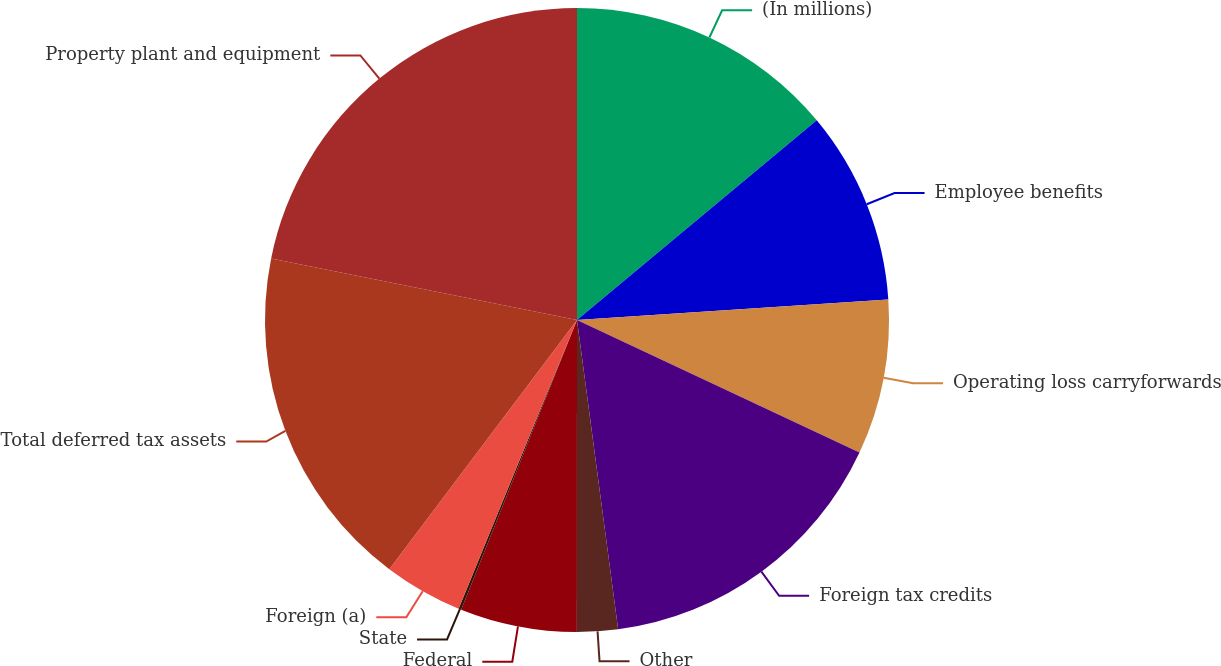Convert chart. <chart><loc_0><loc_0><loc_500><loc_500><pie_chart><fcel>(In millions)<fcel>Employee benefits<fcel>Operating loss carryforwards<fcel>Foreign tax credits<fcel>Other<fcel>Federal<fcel>State<fcel>Foreign (a)<fcel>Total deferred tax assets<fcel>Property plant and equipment<nl><fcel>13.95%<fcel>10.0%<fcel>8.03%<fcel>15.92%<fcel>2.11%<fcel>6.05%<fcel>0.14%<fcel>4.08%<fcel>17.89%<fcel>21.84%<nl></chart> 